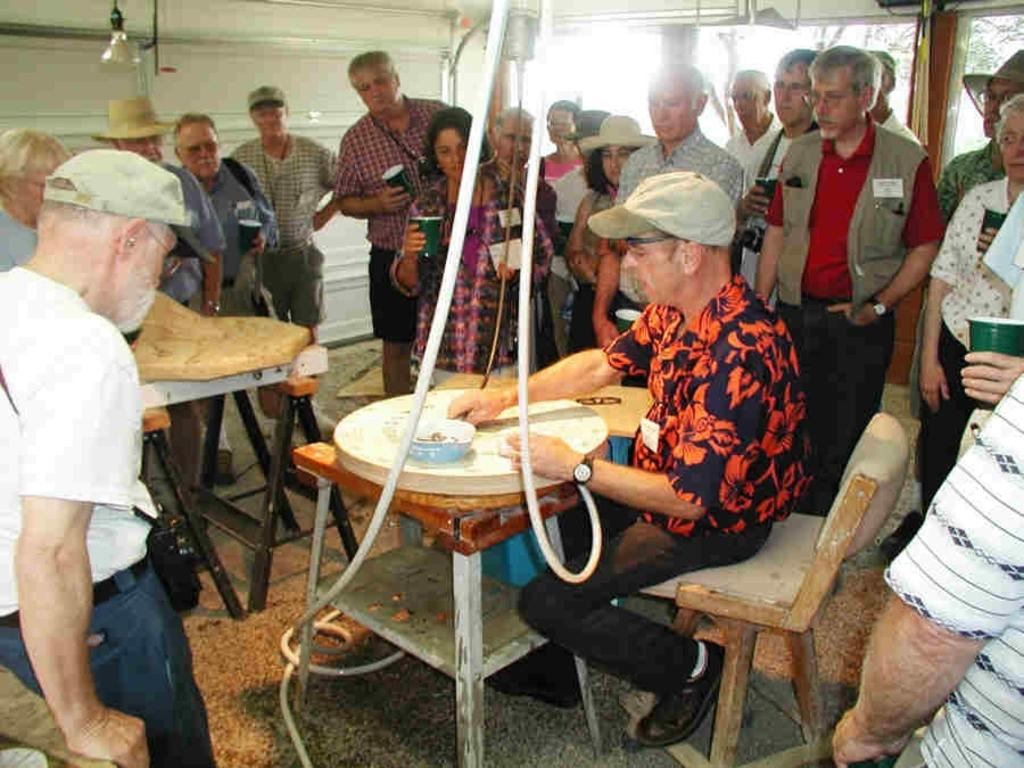How many people are in the image? There is a group of people standing in the image. What is the man in the image doing? The man is seated on a chair in the image. What is the man holding in his hand? The man is holding a bowl in his hand. What amusement park rule is being broken by the group of people in the image? There is no indication of an amusement park or any rules being broken in the image. 